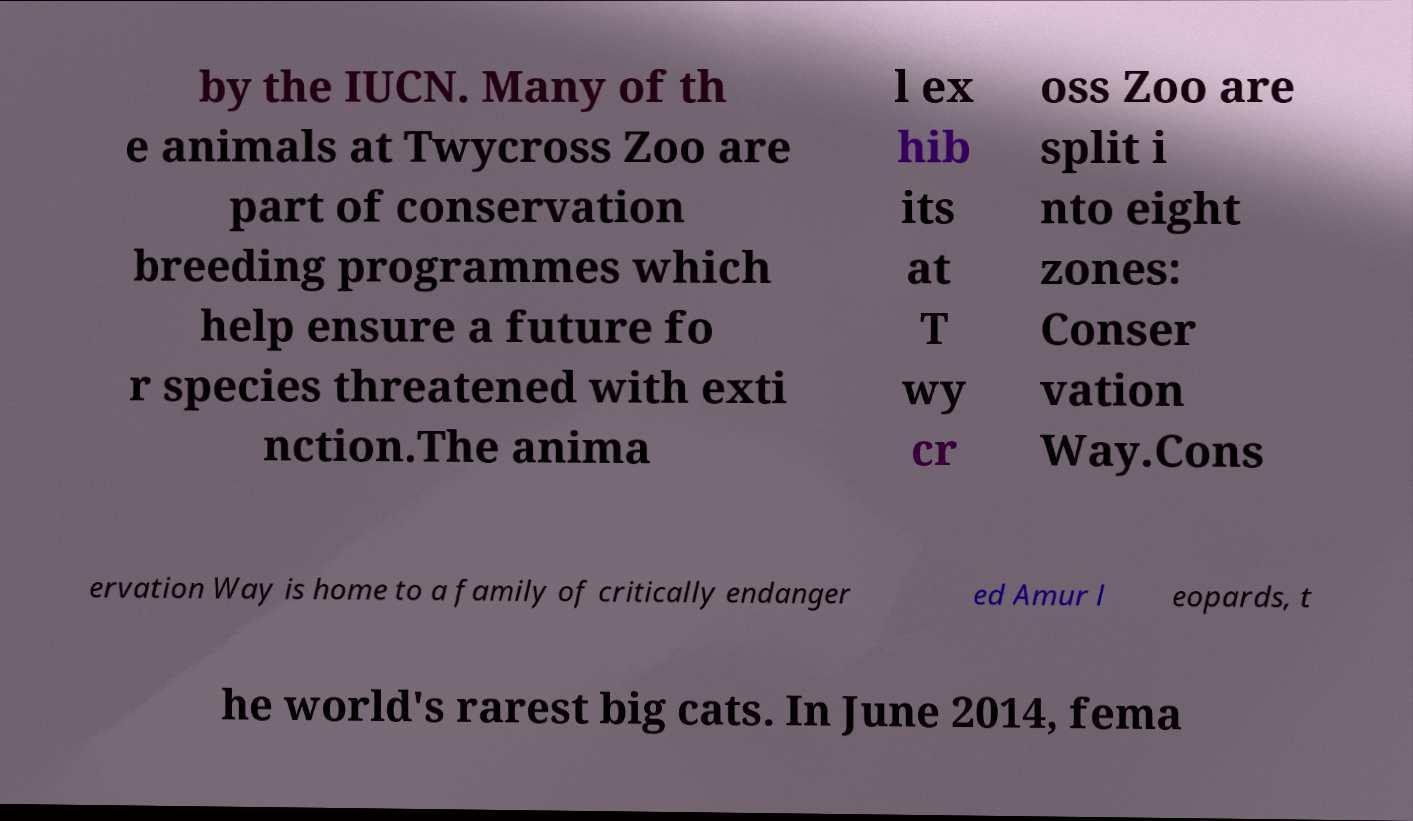Please identify and transcribe the text found in this image. by the IUCN. Many of th e animals at Twycross Zoo are part of conservation breeding programmes which help ensure a future fo r species threatened with exti nction.The anima l ex hib its at T wy cr oss Zoo are split i nto eight zones: Conser vation Way.Cons ervation Way is home to a family of critically endanger ed Amur l eopards, t he world's rarest big cats. In June 2014, fema 